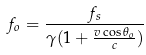Convert formula to latex. <formula><loc_0><loc_0><loc_500><loc_500>f _ { o } = \frac { f _ { s } } { \gamma ( 1 + \frac { v \cos \theta _ { o } } { c } ) }</formula> 